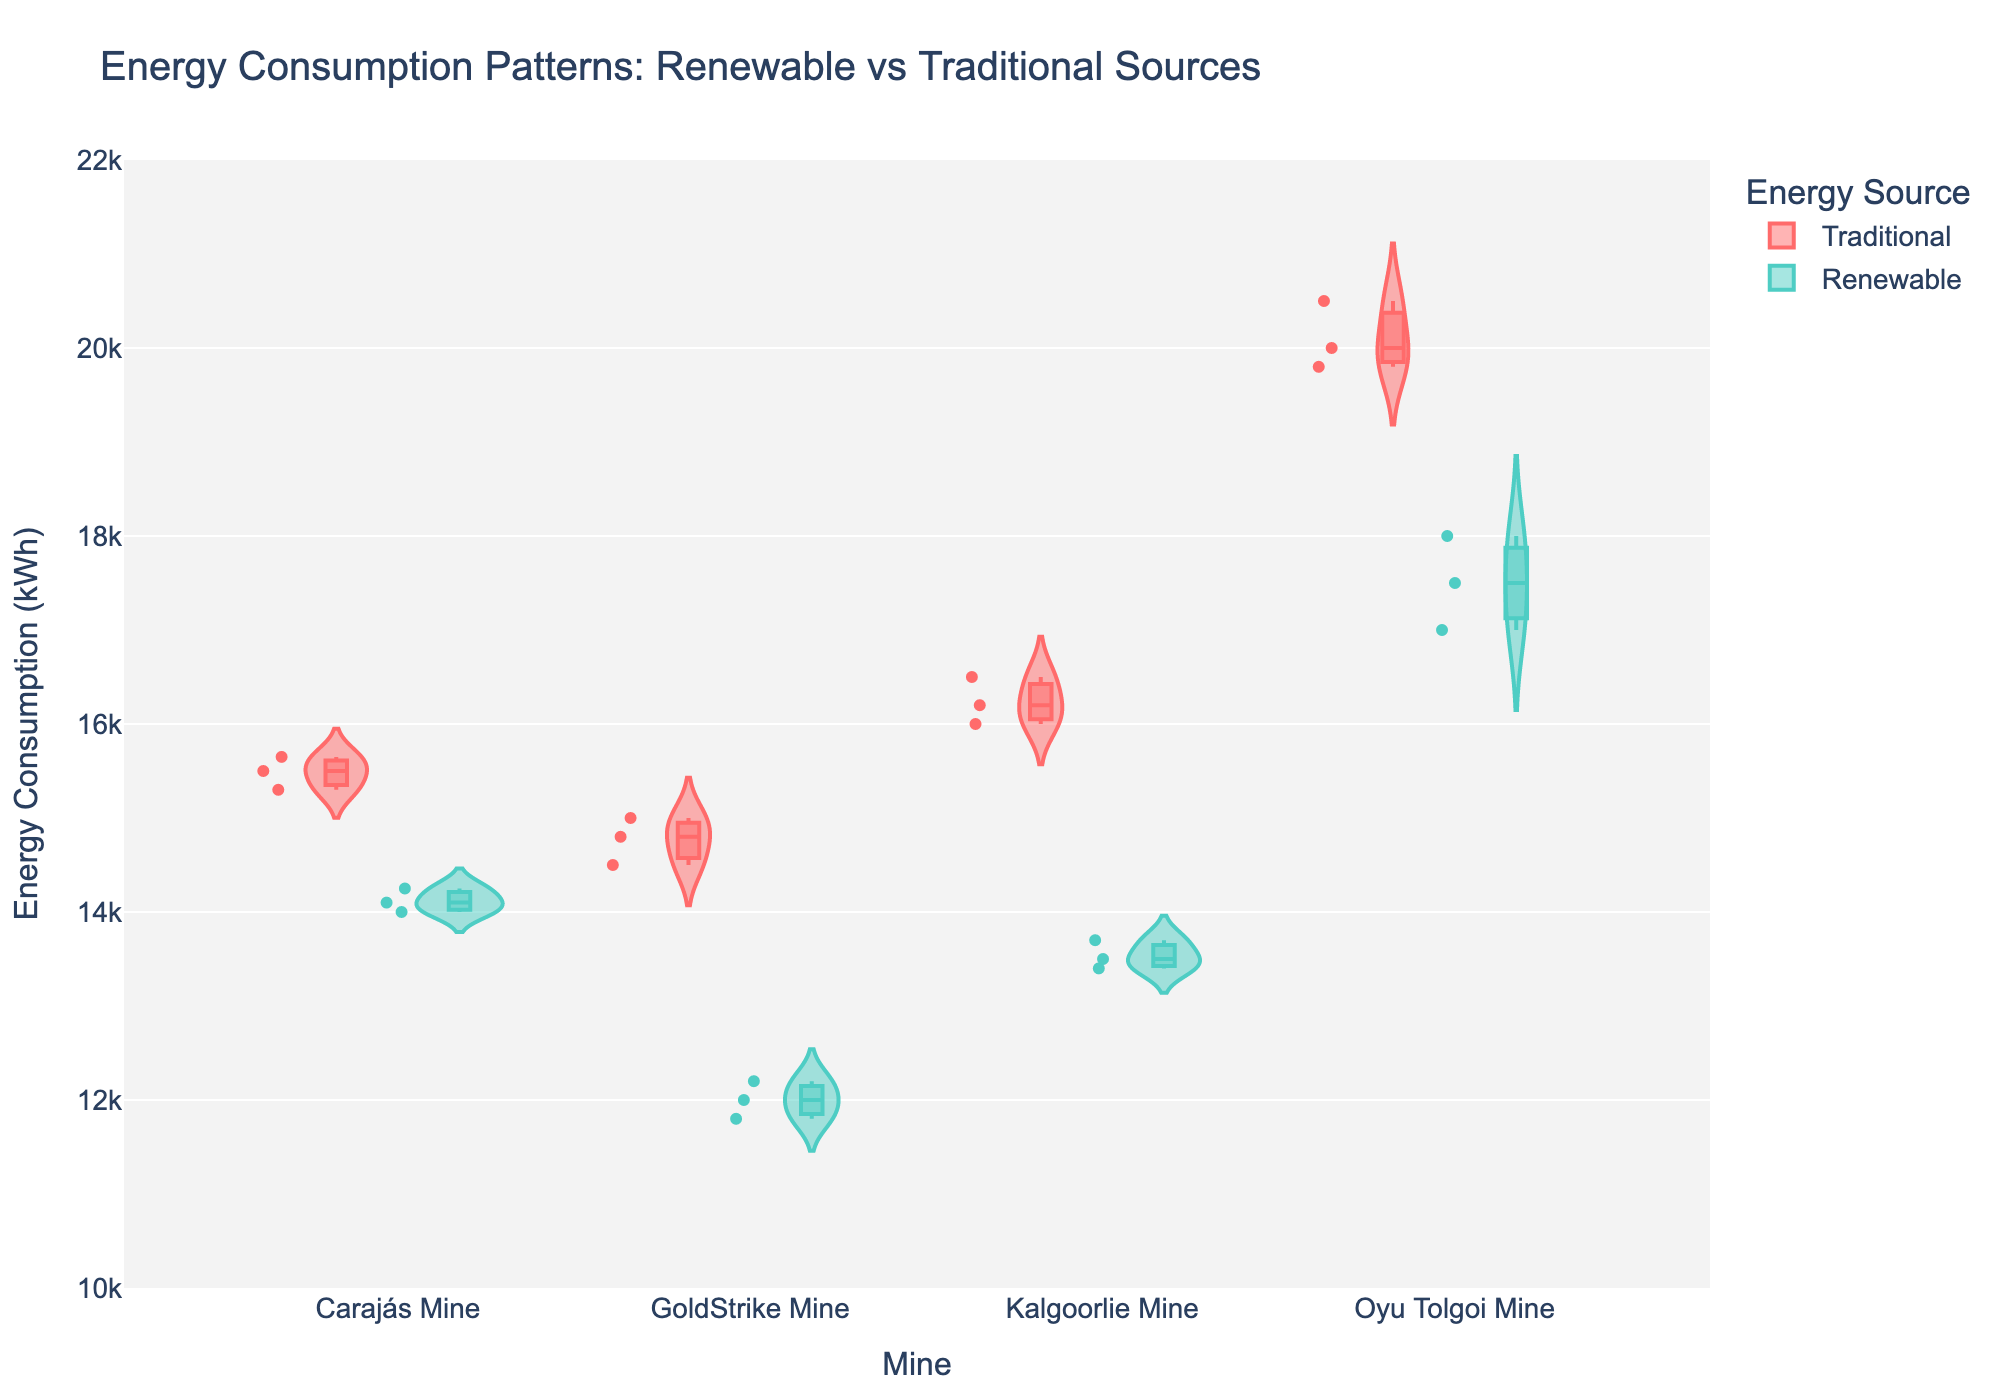What is the title of the figure? The title is located at the top of the figure. It summarizes the overall theme or focus of the visual representation.
Answer: Energy Consumption Patterns: Renewable vs Traditional Sources What are the color representations for renewable and traditional energy sources? The color legend should indicate which colors represent different energy sources. Renewable energy sources are shown in greenish-blue, and traditional energy sources are shown in red.
Answer: Renewable: greenish-blue, Traditional: red Which mine has the highest median energy consumption when using traditional energy sources? By observing the position of the box inside the violin plot for the traditional energy source, the median corresponds to the line within the box. The mine with the highest median line for traditional energy is Oyu Tolgoi Mine.
Answer: Oyu Tolgoi Mine What is the range of energy consumption values displayed on the y-axis? The y-axis ranges from the minimum to the maximum values indicated next to the axis. This range defines the energy consumption values.
Answer: 10,000 to 22,000 kWh Are there any mines that show a higher median energy consumption with renewable energy sources compared to another mine's traditional energy sources? Compare the median lines (inside the boxes) for renewable sources with those for traditional sources across different mines. The higher median for renewable energy compared to traditional energy of another mine is not observed here.
Answer: No Which mine shows the least variability in energy consumption for renewable energy sources? Variability can be determined by observing the width of the violin plot. The narrower the violin plot, the less variability it indicates. Kalgoorlie Mine has the least variability in the renewable energy source category.
Answer: Kalgoorlie Mine How does the distribution of energy consumption for Carajás Mine using traditional energy compare with renewable energy? Look at the shape and spread of the violin plots. The traditional energy source has a wider and higher distribution than the renewable, meaning it has more variability and higher consumption.
Answer: Traditional has a wider and higher distribution What's the difference in the median energy consumption between traditional and renewable sources for GoldStrike Mine? Identify the median lines inside the boxes for both energy sources, then subtract the renewable median from the traditional median for GoldStrike Mine.
Answer: 3000 kWh How does the renewable energy consumption distribution for Oyu Tolgoi Mine compare to that of Kalgoorlie Mine? Compare the shape and spread of the violin plots of renewable energy sources for both mines. Oyu Tolgoi Mine has a higher and wider distribution compared to Kalgoorlie Mine, indicating higher energy consumption and more variability.
Answer: Oyu Tolgoi has higher and wider distribution Which mine appears to benefit most from switching to renewable energy in terms of lowering median energy consumption? Look at the difference in medians for each mine. The larger the reduction, the more benefit it demonstrates. GoldStrike Mine shows the most substantial reduction in median energy consumption.
Answer: GoldStrike Mine 